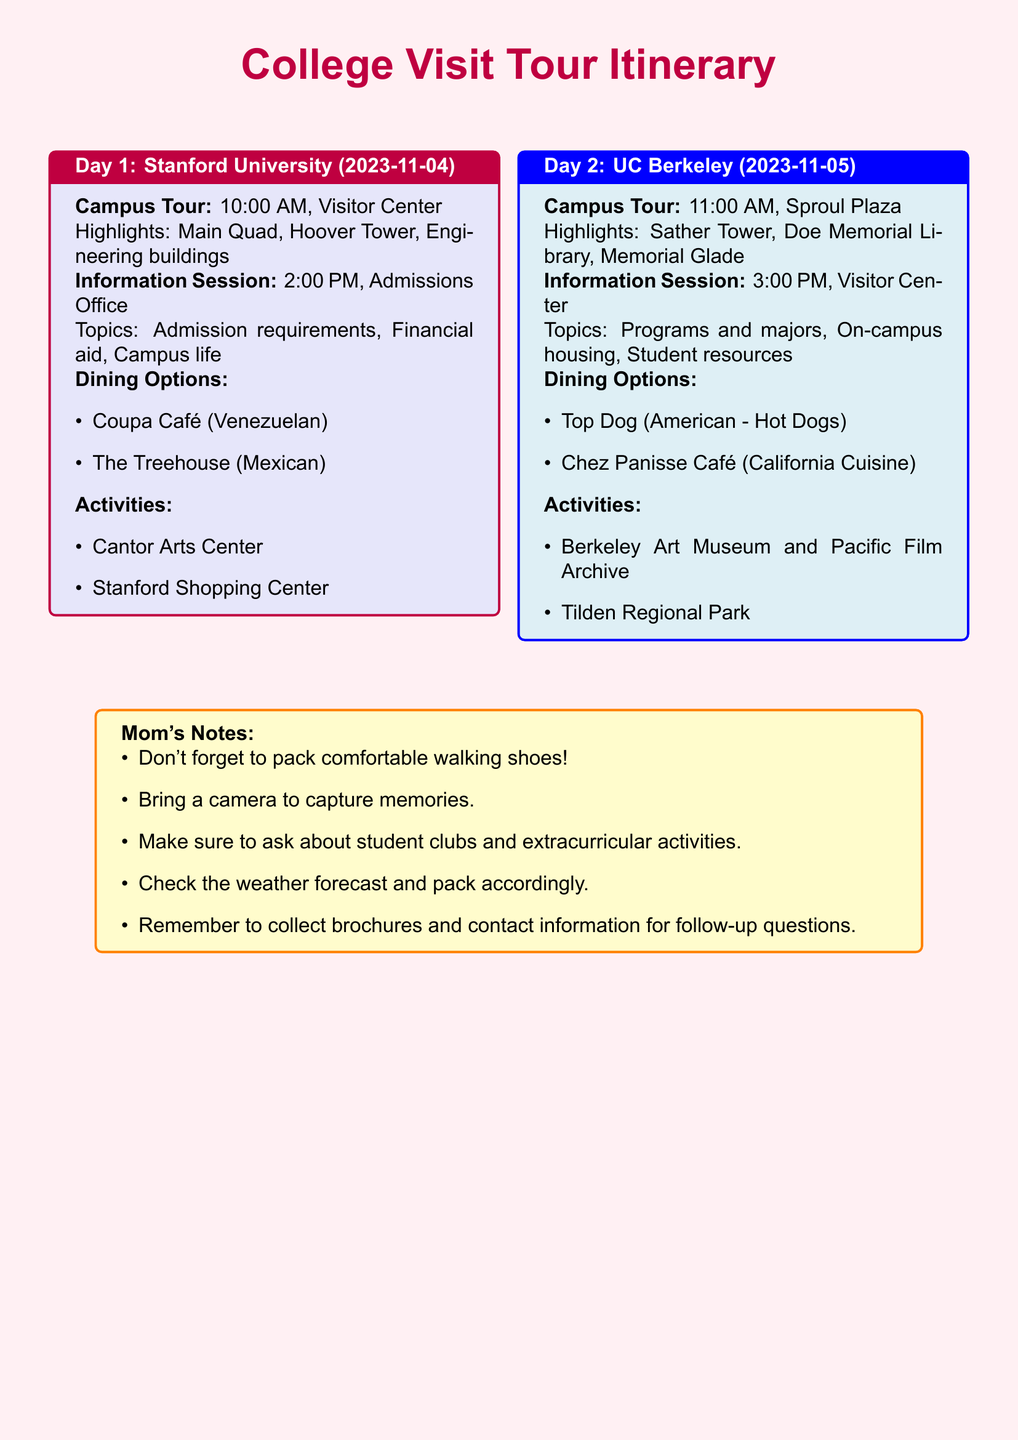What time is the campus tour at Stanford University? The campus tour at Stanford University is scheduled for 10:00 AM.
Answer: 10:00 AM What are the two dining options listed for Day 1? The dining options for Day 1 include Coupa Café and The Treehouse.
Answer: Coupa Café, The Treehouse Which activity is listed for the afternoon of Day 1? The information session at Stanford University is scheduled for 2:00 PM in the Admissions Office.
Answer: Information Session What is the highlight of the campus tour at UC Berkeley? One of the highlights of the campus tour at UC Berkeley is Sather Tower.
Answer: Sather Tower What advice does the Mom's Notes box give about footwear? It suggests packing comfortable walking shoes.
Answer: Comfortable walking shoes What is the total number of planned information sessions across both days? There is one information session for each day, totaling two information sessions.
Answer: 2 Which park is mentioned as an activity for Day 2? Tilden Regional Park is mentioned as an activity for Day 2.
Answer: Tilden Regional Park What time does the information session start at UC Berkeley? The information session at UC Berkeley starts at 3:00 PM.
Answer: 3:00 PM What type of cuisine does Chez Panisse Café serve? Chez Panisse Café serves California Cuisine.
Answer: California Cuisine 